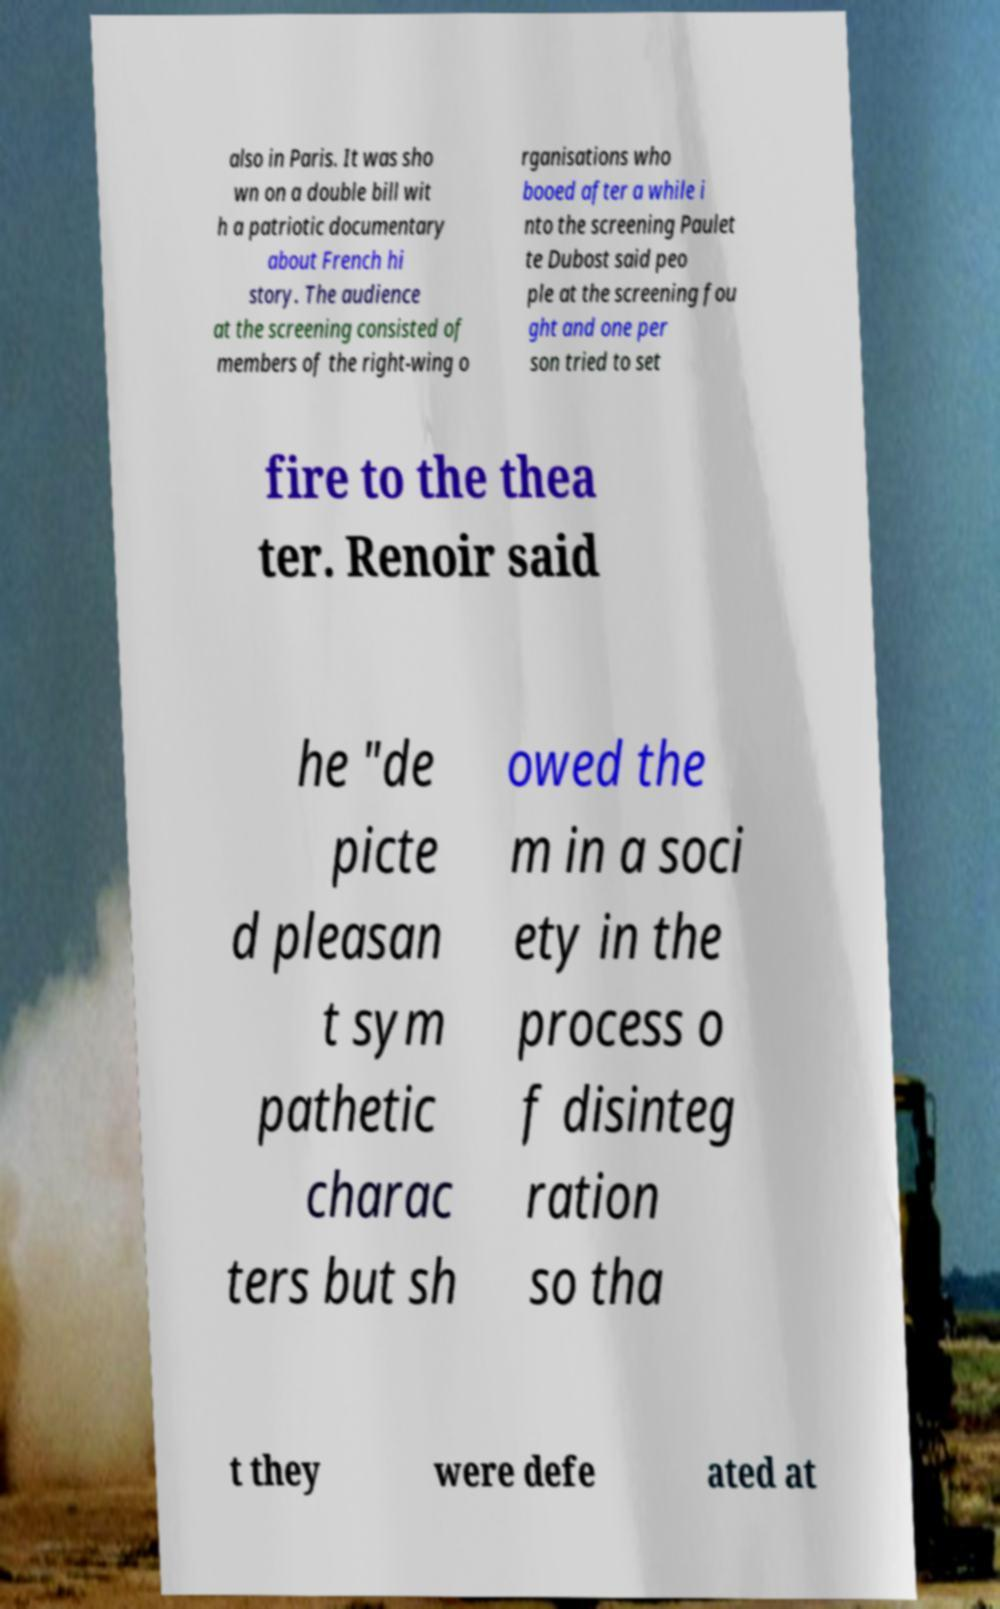Can you accurately transcribe the text from the provided image for me? also in Paris. It was sho wn on a double bill wit h a patriotic documentary about French hi story. The audience at the screening consisted of members of the right-wing o rganisations who booed after a while i nto the screening Paulet te Dubost said peo ple at the screening fou ght and one per son tried to set fire to the thea ter. Renoir said he "de picte d pleasan t sym pathetic charac ters but sh owed the m in a soci ety in the process o f disinteg ration so tha t they were defe ated at 